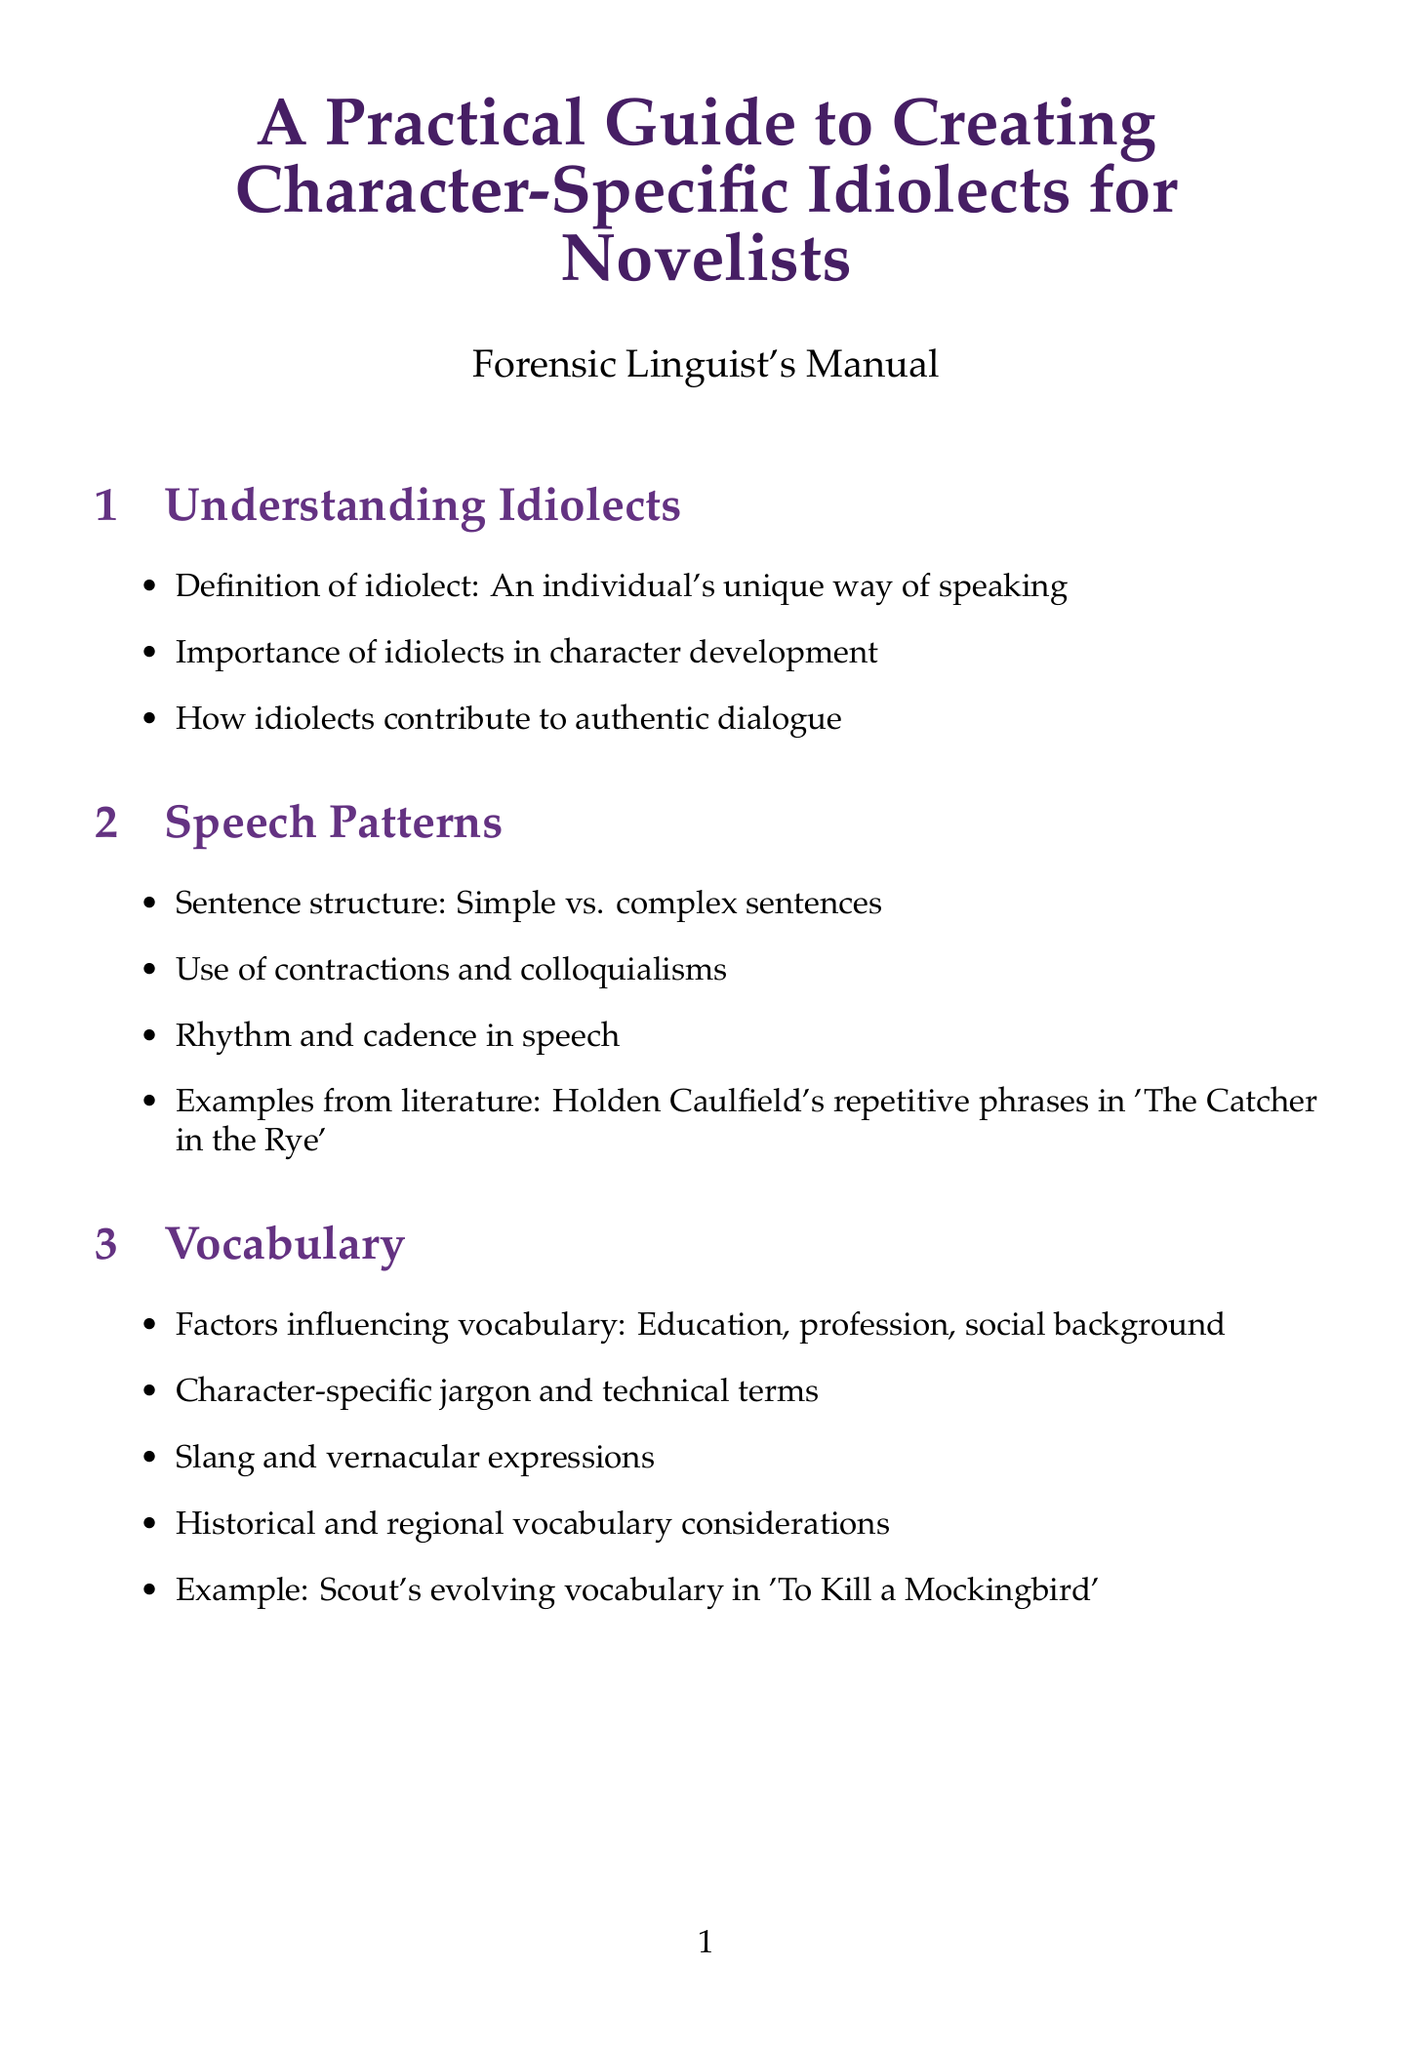what is the title of the document? The title of the document is stated in the header and introduction.
Answer: A Practical Guide to Creating Character-Specific Idiolects for Novelists how many sections are in the document? The document outlines several sections that cover different aspects of idiolects and speech patterns.
Answer: 9 who is interviewed in the Expert Insights section? The Expert Insights section mentions a linguist and author as well as other experts contributing their tips.
Answer: Dr. David Crystal which character's speech patterns are mentioned as an example in the vocabulary section? The example given in the vocabulary section demonstrates a character's evolving language over time.
Answer: Scout what is an example of verbal tics mentioned in the document? The document lists common verbal tics which are frequently used filler words in speech.
Answer: um what aspect does the sociolinguistic factors section focus on? The section explores various influences on an individual's speech styles.
Answer: Age-related speech patterns name a tool listed in the Tools and Resources section. The Tools and Resources section provides items that assist writers in creating authentic character dialogue.
Answer: Urban Dictionary what common pitfall is stated in the manual regarding language use? The common pitfalls section lists mistakes writers might make when depicting character speech.
Answer: Overuse of phonetic spelling 